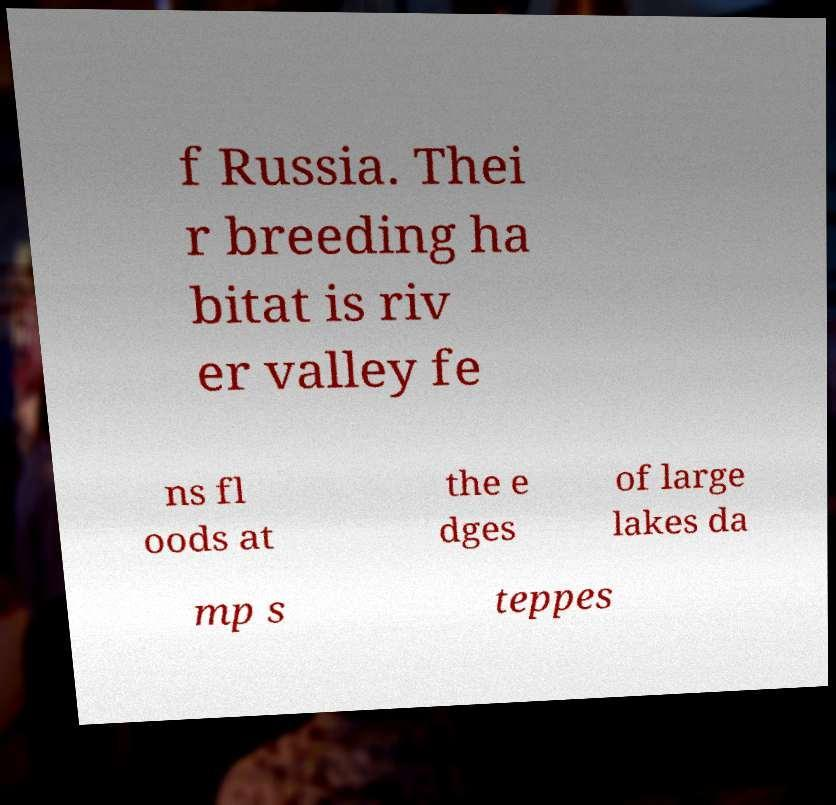Please read and relay the text visible in this image. What does it say? f Russia. Thei r breeding ha bitat is riv er valley fe ns fl oods at the e dges of large lakes da mp s teppes 